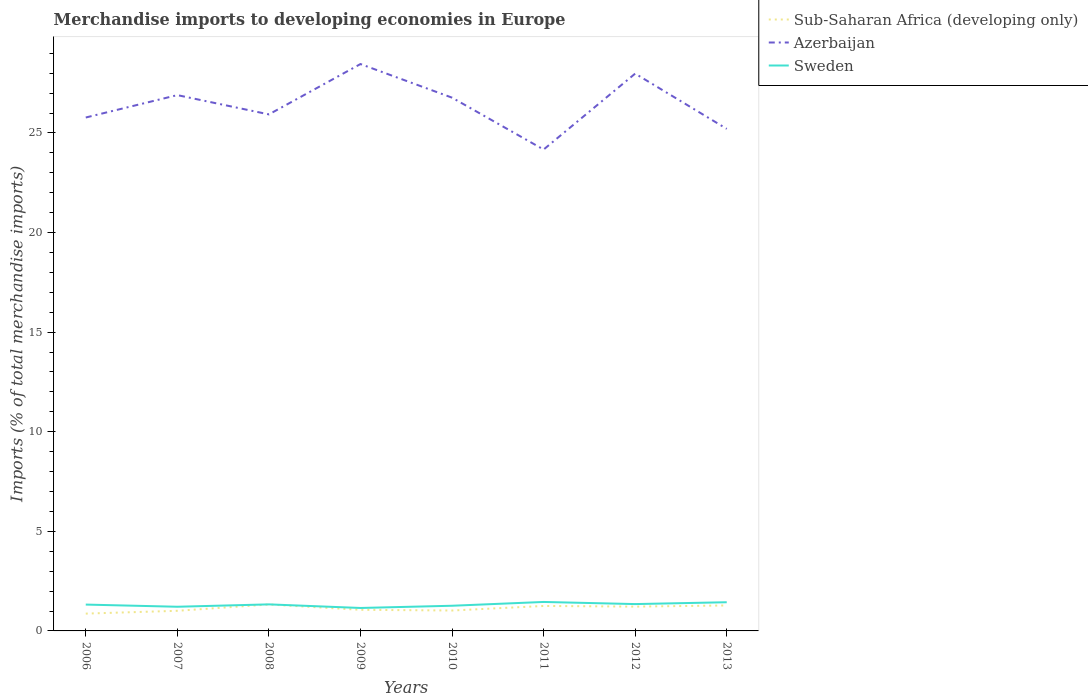How many different coloured lines are there?
Give a very brief answer. 3. Does the line corresponding to Azerbaijan intersect with the line corresponding to Sub-Saharan Africa (developing only)?
Provide a short and direct response. No. Is the number of lines equal to the number of legend labels?
Your answer should be compact. Yes. Across all years, what is the maximum percentage total merchandise imports in Azerbaijan?
Make the answer very short. 24.17. What is the total percentage total merchandise imports in Azerbaijan in the graph?
Give a very brief answer. -1.12. What is the difference between the highest and the second highest percentage total merchandise imports in Azerbaijan?
Offer a terse response. 4.29. What is the difference between the highest and the lowest percentage total merchandise imports in Sweden?
Provide a short and direct response. 5. How many lines are there?
Keep it short and to the point. 3. What is the difference between two consecutive major ticks on the Y-axis?
Make the answer very short. 5. Does the graph contain any zero values?
Make the answer very short. No. Where does the legend appear in the graph?
Provide a succinct answer. Top right. How many legend labels are there?
Provide a succinct answer. 3. How are the legend labels stacked?
Your answer should be compact. Vertical. What is the title of the graph?
Ensure brevity in your answer.  Merchandise imports to developing economies in Europe. What is the label or title of the X-axis?
Ensure brevity in your answer.  Years. What is the label or title of the Y-axis?
Offer a very short reply. Imports (% of total merchandise imports). What is the Imports (% of total merchandise imports) in Sub-Saharan Africa (developing only) in 2006?
Your answer should be compact. 0.87. What is the Imports (% of total merchandise imports) of Azerbaijan in 2006?
Your answer should be compact. 25.77. What is the Imports (% of total merchandise imports) of Sweden in 2006?
Provide a short and direct response. 1.32. What is the Imports (% of total merchandise imports) in Sub-Saharan Africa (developing only) in 2007?
Provide a succinct answer. 1.01. What is the Imports (% of total merchandise imports) in Azerbaijan in 2007?
Your response must be concise. 26.9. What is the Imports (% of total merchandise imports) in Sweden in 2007?
Your answer should be very brief. 1.21. What is the Imports (% of total merchandise imports) of Sub-Saharan Africa (developing only) in 2008?
Your answer should be very brief. 1.33. What is the Imports (% of total merchandise imports) of Azerbaijan in 2008?
Provide a short and direct response. 25.93. What is the Imports (% of total merchandise imports) in Sweden in 2008?
Give a very brief answer. 1.33. What is the Imports (% of total merchandise imports) of Sub-Saharan Africa (developing only) in 2009?
Ensure brevity in your answer.  1.06. What is the Imports (% of total merchandise imports) of Azerbaijan in 2009?
Make the answer very short. 28.46. What is the Imports (% of total merchandise imports) in Sweden in 2009?
Your answer should be compact. 1.15. What is the Imports (% of total merchandise imports) in Sub-Saharan Africa (developing only) in 2010?
Provide a succinct answer. 1.02. What is the Imports (% of total merchandise imports) of Azerbaijan in 2010?
Your answer should be very brief. 26.77. What is the Imports (% of total merchandise imports) of Sweden in 2010?
Provide a succinct answer. 1.26. What is the Imports (% of total merchandise imports) in Sub-Saharan Africa (developing only) in 2011?
Keep it short and to the point. 1.25. What is the Imports (% of total merchandise imports) in Azerbaijan in 2011?
Offer a very short reply. 24.17. What is the Imports (% of total merchandise imports) in Sweden in 2011?
Offer a terse response. 1.45. What is the Imports (% of total merchandise imports) of Sub-Saharan Africa (developing only) in 2012?
Offer a very short reply. 1.22. What is the Imports (% of total merchandise imports) in Azerbaijan in 2012?
Your response must be concise. 27.98. What is the Imports (% of total merchandise imports) of Sweden in 2012?
Offer a very short reply. 1.35. What is the Imports (% of total merchandise imports) of Sub-Saharan Africa (developing only) in 2013?
Ensure brevity in your answer.  1.28. What is the Imports (% of total merchandise imports) in Azerbaijan in 2013?
Give a very brief answer. 25.2. What is the Imports (% of total merchandise imports) of Sweden in 2013?
Give a very brief answer. 1.44. Across all years, what is the maximum Imports (% of total merchandise imports) in Sub-Saharan Africa (developing only)?
Offer a very short reply. 1.33. Across all years, what is the maximum Imports (% of total merchandise imports) in Azerbaijan?
Offer a terse response. 28.46. Across all years, what is the maximum Imports (% of total merchandise imports) of Sweden?
Make the answer very short. 1.45. Across all years, what is the minimum Imports (% of total merchandise imports) of Sub-Saharan Africa (developing only)?
Make the answer very short. 0.87. Across all years, what is the minimum Imports (% of total merchandise imports) of Azerbaijan?
Ensure brevity in your answer.  24.17. Across all years, what is the minimum Imports (% of total merchandise imports) in Sweden?
Your response must be concise. 1.15. What is the total Imports (% of total merchandise imports) in Sub-Saharan Africa (developing only) in the graph?
Offer a very short reply. 9.04. What is the total Imports (% of total merchandise imports) in Azerbaijan in the graph?
Keep it short and to the point. 211.18. What is the total Imports (% of total merchandise imports) of Sweden in the graph?
Provide a short and direct response. 10.53. What is the difference between the Imports (% of total merchandise imports) of Sub-Saharan Africa (developing only) in 2006 and that in 2007?
Offer a very short reply. -0.14. What is the difference between the Imports (% of total merchandise imports) of Azerbaijan in 2006 and that in 2007?
Your answer should be very brief. -1.12. What is the difference between the Imports (% of total merchandise imports) of Sweden in 2006 and that in 2007?
Offer a terse response. 0.11. What is the difference between the Imports (% of total merchandise imports) in Sub-Saharan Africa (developing only) in 2006 and that in 2008?
Keep it short and to the point. -0.46. What is the difference between the Imports (% of total merchandise imports) of Azerbaijan in 2006 and that in 2008?
Ensure brevity in your answer.  -0.16. What is the difference between the Imports (% of total merchandise imports) in Sweden in 2006 and that in 2008?
Give a very brief answer. -0.01. What is the difference between the Imports (% of total merchandise imports) of Sub-Saharan Africa (developing only) in 2006 and that in 2009?
Offer a very short reply. -0.19. What is the difference between the Imports (% of total merchandise imports) of Azerbaijan in 2006 and that in 2009?
Give a very brief answer. -2.68. What is the difference between the Imports (% of total merchandise imports) in Sweden in 2006 and that in 2009?
Keep it short and to the point. 0.17. What is the difference between the Imports (% of total merchandise imports) in Sub-Saharan Africa (developing only) in 2006 and that in 2010?
Make the answer very short. -0.16. What is the difference between the Imports (% of total merchandise imports) in Azerbaijan in 2006 and that in 2010?
Your answer should be very brief. -1. What is the difference between the Imports (% of total merchandise imports) of Sweden in 2006 and that in 2010?
Offer a very short reply. 0.06. What is the difference between the Imports (% of total merchandise imports) in Sub-Saharan Africa (developing only) in 2006 and that in 2011?
Your answer should be compact. -0.38. What is the difference between the Imports (% of total merchandise imports) in Azerbaijan in 2006 and that in 2011?
Ensure brevity in your answer.  1.61. What is the difference between the Imports (% of total merchandise imports) of Sweden in 2006 and that in 2011?
Your answer should be compact. -0.13. What is the difference between the Imports (% of total merchandise imports) in Sub-Saharan Africa (developing only) in 2006 and that in 2012?
Offer a terse response. -0.35. What is the difference between the Imports (% of total merchandise imports) in Azerbaijan in 2006 and that in 2012?
Make the answer very short. -2.2. What is the difference between the Imports (% of total merchandise imports) in Sweden in 2006 and that in 2012?
Make the answer very short. -0.03. What is the difference between the Imports (% of total merchandise imports) in Sub-Saharan Africa (developing only) in 2006 and that in 2013?
Give a very brief answer. -0.41. What is the difference between the Imports (% of total merchandise imports) of Azerbaijan in 2006 and that in 2013?
Keep it short and to the point. 0.57. What is the difference between the Imports (% of total merchandise imports) in Sweden in 2006 and that in 2013?
Ensure brevity in your answer.  -0.12. What is the difference between the Imports (% of total merchandise imports) of Sub-Saharan Africa (developing only) in 2007 and that in 2008?
Ensure brevity in your answer.  -0.32. What is the difference between the Imports (% of total merchandise imports) in Azerbaijan in 2007 and that in 2008?
Keep it short and to the point. 0.97. What is the difference between the Imports (% of total merchandise imports) of Sweden in 2007 and that in 2008?
Give a very brief answer. -0.12. What is the difference between the Imports (% of total merchandise imports) of Sub-Saharan Africa (developing only) in 2007 and that in 2009?
Offer a terse response. -0.05. What is the difference between the Imports (% of total merchandise imports) in Azerbaijan in 2007 and that in 2009?
Provide a short and direct response. -1.56. What is the difference between the Imports (% of total merchandise imports) of Sweden in 2007 and that in 2009?
Provide a short and direct response. 0.06. What is the difference between the Imports (% of total merchandise imports) of Sub-Saharan Africa (developing only) in 2007 and that in 2010?
Make the answer very short. -0.01. What is the difference between the Imports (% of total merchandise imports) of Azerbaijan in 2007 and that in 2010?
Your response must be concise. 0.13. What is the difference between the Imports (% of total merchandise imports) of Sweden in 2007 and that in 2010?
Keep it short and to the point. -0.05. What is the difference between the Imports (% of total merchandise imports) of Sub-Saharan Africa (developing only) in 2007 and that in 2011?
Offer a terse response. -0.24. What is the difference between the Imports (% of total merchandise imports) of Azerbaijan in 2007 and that in 2011?
Your answer should be very brief. 2.73. What is the difference between the Imports (% of total merchandise imports) in Sweden in 2007 and that in 2011?
Keep it short and to the point. -0.24. What is the difference between the Imports (% of total merchandise imports) in Sub-Saharan Africa (developing only) in 2007 and that in 2012?
Your response must be concise. -0.21. What is the difference between the Imports (% of total merchandise imports) in Azerbaijan in 2007 and that in 2012?
Give a very brief answer. -1.08. What is the difference between the Imports (% of total merchandise imports) in Sweden in 2007 and that in 2012?
Make the answer very short. -0.13. What is the difference between the Imports (% of total merchandise imports) in Sub-Saharan Africa (developing only) in 2007 and that in 2013?
Make the answer very short. -0.27. What is the difference between the Imports (% of total merchandise imports) of Azerbaijan in 2007 and that in 2013?
Ensure brevity in your answer.  1.69. What is the difference between the Imports (% of total merchandise imports) of Sweden in 2007 and that in 2013?
Provide a short and direct response. -0.23. What is the difference between the Imports (% of total merchandise imports) in Sub-Saharan Africa (developing only) in 2008 and that in 2009?
Keep it short and to the point. 0.27. What is the difference between the Imports (% of total merchandise imports) in Azerbaijan in 2008 and that in 2009?
Make the answer very short. -2.53. What is the difference between the Imports (% of total merchandise imports) of Sweden in 2008 and that in 2009?
Make the answer very short. 0.18. What is the difference between the Imports (% of total merchandise imports) of Sub-Saharan Africa (developing only) in 2008 and that in 2010?
Offer a very short reply. 0.3. What is the difference between the Imports (% of total merchandise imports) of Azerbaijan in 2008 and that in 2010?
Your response must be concise. -0.84. What is the difference between the Imports (% of total merchandise imports) of Sweden in 2008 and that in 2010?
Provide a short and direct response. 0.07. What is the difference between the Imports (% of total merchandise imports) of Sub-Saharan Africa (developing only) in 2008 and that in 2011?
Keep it short and to the point. 0.07. What is the difference between the Imports (% of total merchandise imports) in Azerbaijan in 2008 and that in 2011?
Give a very brief answer. 1.76. What is the difference between the Imports (% of total merchandise imports) of Sweden in 2008 and that in 2011?
Ensure brevity in your answer.  -0.12. What is the difference between the Imports (% of total merchandise imports) in Sub-Saharan Africa (developing only) in 2008 and that in 2012?
Make the answer very short. 0.11. What is the difference between the Imports (% of total merchandise imports) in Azerbaijan in 2008 and that in 2012?
Make the answer very short. -2.05. What is the difference between the Imports (% of total merchandise imports) in Sweden in 2008 and that in 2012?
Your answer should be compact. -0.01. What is the difference between the Imports (% of total merchandise imports) in Sub-Saharan Africa (developing only) in 2008 and that in 2013?
Offer a terse response. 0.05. What is the difference between the Imports (% of total merchandise imports) in Azerbaijan in 2008 and that in 2013?
Provide a succinct answer. 0.73. What is the difference between the Imports (% of total merchandise imports) of Sweden in 2008 and that in 2013?
Offer a terse response. -0.11. What is the difference between the Imports (% of total merchandise imports) in Sub-Saharan Africa (developing only) in 2009 and that in 2010?
Keep it short and to the point. 0.04. What is the difference between the Imports (% of total merchandise imports) in Azerbaijan in 2009 and that in 2010?
Provide a short and direct response. 1.69. What is the difference between the Imports (% of total merchandise imports) in Sweden in 2009 and that in 2010?
Offer a very short reply. -0.11. What is the difference between the Imports (% of total merchandise imports) in Sub-Saharan Africa (developing only) in 2009 and that in 2011?
Offer a very short reply. -0.19. What is the difference between the Imports (% of total merchandise imports) of Azerbaijan in 2009 and that in 2011?
Provide a short and direct response. 4.29. What is the difference between the Imports (% of total merchandise imports) in Sweden in 2009 and that in 2011?
Offer a terse response. -0.3. What is the difference between the Imports (% of total merchandise imports) of Sub-Saharan Africa (developing only) in 2009 and that in 2012?
Your answer should be compact. -0.16. What is the difference between the Imports (% of total merchandise imports) in Azerbaijan in 2009 and that in 2012?
Your response must be concise. 0.48. What is the difference between the Imports (% of total merchandise imports) of Sweden in 2009 and that in 2012?
Offer a very short reply. -0.19. What is the difference between the Imports (% of total merchandise imports) in Sub-Saharan Africa (developing only) in 2009 and that in 2013?
Make the answer very short. -0.22. What is the difference between the Imports (% of total merchandise imports) in Azerbaijan in 2009 and that in 2013?
Your answer should be compact. 3.25. What is the difference between the Imports (% of total merchandise imports) in Sweden in 2009 and that in 2013?
Make the answer very short. -0.29. What is the difference between the Imports (% of total merchandise imports) in Sub-Saharan Africa (developing only) in 2010 and that in 2011?
Offer a very short reply. -0.23. What is the difference between the Imports (% of total merchandise imports) in Azerbaijan in 2010 and that in 2011?
Keep it short and to the point. 2.6. What is the difference between the Imports (% of total merchandise imports) in Sweden in 2010 and that in 2011?
Your answer should be compact. -0.19. What is the difference between the Imports (% of total merchandise imports) in Sub-Saharan Africa (developing only) in 2010 and that in 2012?
Make the answer very short. -0.2. What is the difference between the Imports (% of total merchandise imports) in Azerbaijan in 2010 and that in 2012?
Your answer should be very brief. -1.21. What is the difference between the Imports (% of total merchandise imports) of Sweden in 2010 and that in 2012?
Provide a short and direct response. -0.08. What is the difference between the Imports (% of total merchandise imports) in Sub-Saharan Africa (developing only) in 2010 and that in 2013?
Your answer should be compact. -0.25. What is the difference between the Imports (% of total merchandise imports) of Azerbaijan in 2010 and that in 2013?
Your answer should be compact. 1.57. What is the difference between the Imports (% of total merchandise imports) in Sweden in 2010 and that in 2013?
Your response must be concise. -0.18. What is the difference between the Imports (% of total merchandise imports) in Sub-Saharan Africa (developing only) in 2011 and that in 2012?
Ensure brevity in your answer.  0.03. What is the difference between the Imports (% of total merchandise imports) in Azerbaijan in 2011 and that in 2012?
Offer a very short reply. -3.81. What is the difference between the Imports (% of total merchandise imports) of Sweden in 2011 and that in 2012?
Make the answer very short. 0.11. What is the difference between the Imports (% of total merchandise imports) in Sub-Saharan Africa (developing only) in 2011 and that in 2013?
Your answer should be very brief. -0.03. What is the difference between the Imports (% of total merchandise imports) in Azerbaijan in 2011 and that in 2013?
Keep it short and to the point. -1.04. What is the difference between the Imports (% of total merchandise imports) of Sweden in 2011 and that in 2013?
Ensure brevity in your answer.  0.01. What is the difference between the Imports (% of total merchandise imports) of Sub-Saharan Africa (developing only) in 2012 and that in 2013?
Keep it short and to the point. -0.06. What is the difference between the Imports (% of total merchandise imports) of Azerbaijan in 2012 and that in 2013?
Make the answer very short. 2.77. What is the difference between the Imports (% of total merchandise imports) of Sweden in 2012 and that in 2013?
Your answer should be very brief. -0.09. What is the difference between the Imports (% of total merchandise imports) of Sub-Saharan Africa (developing only) in 2006 and the Imports (% of total merchandise imports) of Azerbaijan in 2007?
Your response must be concise. -26.03. What is the difference between the Imports (% of total merchandise imports) of Sub-Saharan Africa (developing only) in 2006 and the Imports (% of total merchandise imports) of Sweden in 2007?
Keep it short and to the point. -0.34. What is the difference between the Imports (% of total merchandise imports) in Azerbaijan in 2006 and the Imports (% of total merchandise imports) in Sweden in 2007?
Keep it short and to the point. 24.56. What is the difference between the Imports (% of total merchandise imports) of Sub-Saharan Africa (developing only) in 2006 and the Imports (% of total merchandise imports) of Azerbaijan in 2008?
Give a very brief answer. -25.06. What is the difference between the Imports (% of total merchandise imports) in Sub-Saharan Africa (developing only) in 2006 and the Imports (% of total merchandise imports) in Sweden in 2008?
Keep it short and to the point. -0.46. What is the difference between the Imports (% of total merchandise imports) of Azerbaijan in 2006 and the Imports (% of total merchandise imports) of Sweden in 2008?
Your answer should be very brief. 24.44. What is the difference between the Imports (% of total merchandise imports) of Sub-Saharan Africa (developing only) in 2006 and the Imports (% of total merchandise imports) of Azerbaijan in 2009?
Your answer should be very brief. -27.59. What is the difference between the Imports (% of total merchandise imports) in Sub-Saharan Africa (developing only) in 2006 and the Imports (% of total merchandise imports) in Sweden in 2009?
Offer a terse response. -0.28. What is the difference between the Imports (% of total merchandise imports) in Azerbaijan in 2006 and the Imports (% of total merchandise imports) in Sweden in 2009?
Provide a succinct answer. 24.62. What is the difference between the Imports (% of total merchandise imports) of Sub-Saharan Africa (developing only) in 2006 and the Imports (% of total merchandise imports) of Azerbaijan in 2010?
Provide a succinct answer. -25.9. What is the difference between the Imports (% of total merchandise imports) of Sub-Saharan Africa (developing only) in 2006 and the Imports (% of total merchandise imports) of Sweden in 2010?
Provide a short and direct response. -0.39. What is the difference between the Imports (% of total merchandise imports) in Azerbaijan in 2006 and the Imports (% of total merchandise imports) in Sweden in 2010?
Provide a short and direct response. 24.51. What is the difference between the Imports (% of total merchandise imports) of Sub-Saharan Africa (developing only) in 2006 and the Imports (% of total merchandise imports) of Azerbaijan in 2011?
Provide a short and direct response. -23.3. What is the difference between the Imports (% of total merchandise imports) of Sub-Saharan Africa (developing only) in 2006 and the Imports (% of total merchandise imports) of Sweden in 2011?
Make the answer very short. -0.58. What is the difference between the Imports (% of total merchandise imports) of Azerbaijan in 2006 and the Imports (% of total merchandise imports) of Sweden in 2011?
Provide a short and direct response. 24.32. What is the difference between the Imports (% of total merchandise imports) in Sub-Saharan Africa (developing only) in 2006 and the Imports (% of total merchandise imports) in Azerbaijan in 2012?
Provide a short and direct response. -27.11. What is the difference between the Imports (% of total merchandise imports) of Sub-Saharan Africa (developing only) in 2006 and the Imports (% of total merchandise imports) of Sweden in 2012?
Provide a succinct answer. -0.48. What is the difference between the Imports (% of total merchandise imports) of Azerbaijan in 2006 and the Imports (% of total merchandise imports) of Sweden in 2012?
Provide a succinct answer. 24.43. What is the difference between the Imports (% of total merchandise imports) of Sub-Saharan Africa (developing only) in 2006 and the Imports (% of total merchandise imports) of Azerbaijan in 2013?
Your answer should be very brief. -24.34. What is the difference between the Imports (% of total merchandise imports) in Sub-Saharan Africa (developing only) in 2006 and the Imports (% of total merchandise imports) in Sweden in 2013?
Provide a succinct answer. -0.57. What is the difference between the Imports (% of total merchandise imports) in Azerbaijan in 2006 and the Imports (% of total merchandise imports) in Sweden in 2013?
Your answer should be compact. 24.33. What is the difference between the Imports (% of total merchandise imports) of Sub-Saharan Africa (developing only) in 2007 and the Imports (% of total merchandise imports) of Azerbaijan in 2008?
Provide a succinct answer. -24.92. What is the difference between the Imports (% of total merchandise imports) of Sub-Saharan Africa (developing only) in 2007 and the Imports (% of total merchandise imports) of Sweden in 2008?
Give a very brief answer. -0.32. What is the difference between the Imports (% of total merchandise imports) of Azerbaijan in 2007 and the Imports (% of total merchandise imports) of Sweden in 2008?
Provide a succinct answer. 25.57. What is the difference between the Imports (% of total merchandise imports) of Sub-Saharan Africa (developing only) in 2007 and the Imports (% of total merchandise imports) of Azerbaijan in 2009?
Give a very brief answer. -27.45. What is the difference between the Imports (% of total merchandise imports) in Sub-Saharan Africa (developing only) in 2007 and the Imports (% of total merchandise imports) in Sweden in 2009?
Offer a terse response. -0.14. What is the difference between the Imports (% of total merchandise imports) of Azerbaijan in 2007 and the Imports (% of total merchandise imports) of Sweden in 2009?
Offer a terse response. 25.75. What is the difference between the Imports (% of total merchandise imports) in Sub-Saharan Africa (developing only) in 2007 and the Imports (% of total merchandise imports) in Azerbaijan in 2010?
Keep it short and to the point. -25.76. What is the difference between the Imports (% of total merchandise imports) in Sub-Saharan Africa (developing only) in 2007 and the Imports (% of total merchandise imports) in Sweden in 2010?
Your answer should be very brief. -0.25. What is the difference between the Imports (% of total merchandise imports) of Azerbaijan in 2007 and the Imports (% of total merchandise imports) of Sweden in 2010?
Provide a short and direct response. 25.63. What is the difference between the Imports (% of total merchandise imports) in Sub-Saharan Africa (developing only) in 2007 and the Imports (% of total merchandise imports) in Azerbaijan in 2011?
Ensure brevity in your answer.  -23.16. What is the difference between the Imports (% of total merchandise imports) in Sub-Saharan Africa (developing only) in 2007 and the Imports (% of total merchandise imports) in Sweden in 2011?
Provide a short and direct response. -0.44. What is the difference between the Imports (% of total merchandise imports) of Azerbaijan in 2007 and the Imports (% of total merchandise imports) of Sweden in 2011?
Offer a terse response. 25.44. What is the difference between the Imports (% of total merchandise imports) of Sub-Saharan Africa (developing only) in 2007 and the Imports (% of total merchandise imports) of Azerbaijan in 2012?
Give a very brief answer. -26.97. What is the difference between the Imports (% of total merchandise imports) of Sub-Saharan Africa (developing only) in 2007 and the Imports (% of total merchandise imports) of Sweden in 2012?
Offer a very short reply. -0.34. What is the difference between the Imports (% of total merchandise imports) in Azerbaijan in 2007 and the Imports (% of total merchandise imports) in Sweden in 2012?
Give a very brief answer. 25.55. What is the difference between the Imports (% of total merchandise imports) of Sub-Saharan Africa (developing only) in 2007 and the Imports (% of total merchandise imports) of Azerbaijan in 2013?
Provide a short and direct response. -24.19. What is the difference between the Imports (% of total merchandise imports) of Sub-Saharan Africa (developing only) in 2007 and the Imports (% of total merchandise imports) of Sweden in 2013?
Provide a short and direct response. -0.43. What is the difference between the Imports (% of total merchandise imports) of Azerbaijan in 2007 and the Imports (% of total merchandise imports) of Sweden in 2013?
Provide a short and direct response. 25.46. What is the difference between the Imports (% of total merchandise imports) of Sub-Saharan Africa (developing only) in 2008 and the Imports (% of total merchandise imports) of Azerbaijan in 2009?
Your response must be concise. -27.13. What is the difference between the Imports (% of total merchandise imports) in Sub-Saharan Africa (developing only) in 2008 and the Imports (% of total merchandise imports) in Sweden in 2009?
Offer a terse response. 0.17. What is the difference between the Imports (% of total merchandise imports) in Azerbaijan in 2008 and the Imports (% of total merchandise imports) in Sweden in 2009?
Provide a succinct answer. 24.78. What is the difference between the Imports (% of total merchandise imports) in Sub-Saharan Africa (developing only) in 2008 and the Imports (% of total merchandise imports) in Azerbaijan in 2010?
Offer a terse response. -25.44. What is the difference between the Imports (% of total merchandise imports) of Sub-Saharan Africa (developing only) in 2008 and the Imports (% of total merchandise imports) of Sweden in 2010?
Offer a very short reply. 0.06. What is the difference between the Imports (% of total merchandise imports) in Azerbaijan in 2008 and the Imports (% of total merchandise imports) in Sweden in 2010?
Give a very brief answer. 24.67. What is the difference between the Imports (% of total merchandise imports) in Sub-Saharan Africa (developing only) in 2008 and the Imports (% of total merchandise imports) in Azerbaijan in 2011?
Your answer should be compact. -22.84. What is the difference between the Imports (% of total merchandise imports) in Sub-Saharan Africa (developing only) in 2008 and the Imports (% of total merchandise imports) in Sweden in 2011?
Make the answer very short. -0.13. What is the difference between the Imports (% of total merchandise imports) in Azerbaijan in 2008 and the Imports (% of total merchandise imports) in Sweden in 2011?
Provide a short and direct response. 24.48. What is the difference between the Imports (% of total merchandise imports) in Sub-Saharan Africa (developing only) in 2008 and the Imports (% of total merchandise imports) in Azerbaijan in 2012?
Your response must be concise. -26.65. What is the difference between the Imports (% of total merchandise imports) in Sub-Saharan Africa (developing only) in 2008 and the Imports (% of total merchandise imports) in Sweden in 2012?
Provide a short and direct response. -0.02. What is the difference between the Imports (% of total merchandise imports) in Azerbaijan in 2008 and the Imports (% of total merchandise imports) in Sweden in 2012?
Give a very brief answer. 24.58. What is the difference between the Imports (% of total merchandise imports) in Sub-Saharan Africa (developing only) in 2008 and the Imports (% of total merchandise imports) in Azerbaijan in 2013?
Your response must be concise. -23.88. What is the difference between the Imports (% of total merchandise imports) of Sub-Saharan Africa (developing only) in 2008 and the Imports (% of total merchandise imports) of Sweden in 2013?
Provide a succinct answer. -0.11. What is the difference between the Imports (% of total merchandise imports) of Azerbaijan in 2008 and the Imports (% of total merchandise imports) of Sweden in 2013?
Offer a terse response. 24.49. What is the difference between the Imports (% of total merchandise imports) of Sub-Saharan Africa (developing only) in 2009 and the Imports (% of total merchandise imports) of Azerbaijan in 2010?
Offer a very short reply. -25.71. What is the difference between the Imports (% of total merchandise imports) of Sub-Saharan Africa (developing only) in 2009 and the Imports (% of total merchandise imports) of Sweden in 2010?
Provide a short and direct response. -0.2. What is the difference between the Imports (% of total merchandise imports) of Azerbaijan in 2009 and the Imports (% of total merchandise imports) of Sweden in 2010?
Provide a short and direct response. 27.19. What is the difference between the Imports (% of total merchandise imports) in Sub-Saharan Africa (developing only) in 2009 and the Imports (% of total merchandise imports) in Azerbaijan in 2011?
Your answer should be compact. -23.11. What is the difference between the Imports (% of total merchandise imports) in Sub-Saharan Africa (developing only) in 2009 and the Imports (% of total merchandise imports) in Sweden in 2011?
Offer a very short reply. -0.39. What is the difference between the Imports (% of total merchandise imports) of Azerbaijan in 2009 and the Imports (% of total merchandise imports) of Sweden in 2011?
Provide a succinct answer. 27. What is the difference between the Imports (% of total merchandise imports) of Sub-Saharan Africa (developing only) in 2009 and the Imports (% of total merchandise imports) of Azerbaijan in 2012?
Make the answer very short. -26.92. What is the difference between the Imports (% of total merchandise imports) of Sub-Saharan Africa (developing only) in 2009 and the Imports (% of total merchandise imports) of Sweden in 2012?
Your answer should be very brief. -0.29. What is the difference between the Imports (% of total merchandise imports) of Azerbaijan in 2009 and the Imports (% of total merchandise imports) of Sweden in 2012?
Make the answer very short. 27.11. What is the difference between the Imports (% of total merchandise imports) in Sub-Saharan Africa (developing only) in 2009 and the Imports (% of total merchandise imports) in Azerbaijan in 2013?
Give a very brief answer. -24.14. What is the difference between the Imports (% of total merchandise imports) in Sub-Saharan Africa (developing only) in 2009 and the Imports (% of total merchandise imports) in Sweden in 2013?
Offer a very short reply. -0.38. What is the difference between the Imports (% of total merchandise imports) in Azerbaijan in 2009 and the Imports (% of total merchandise imports) in Sweden in 2013?
Your answer should be very brief. 27.02. What is the difference between the Imports (% of total merchandise imports) of Sub-Saharan Africa (developing only) in 2010 and the Imports (% of total merchandise imports) of Azerbaijan in 2011?
Your answer should be very brief. -23.14. What is the difference between the Imports (% of total merchandise imports) in Sub-Saharan Africa (developing only) in 2010 and the Imports (% of total merchandise imports) in Sweden in 2011?
Ensure brevity in your answer.  -0.43. What is the difference between the Imports (% of total merchandise imports) in Azerbaijan in 2010 and the Imports (% of total merchandise imports) in Sweden in 2011?
Your answer should be very brief. 25.32. What is the difference between the Imports (% of total merchandise imports) of Sub-Saharan Africa (developing only) in 2010 and the Imports (% of total merchandise imports) of Azerbaijan in 2012?
Give a very brief answer. -26.95. What is the difference between the Imports (% of total merchandise imports) of Sub-Saharan Africa (developing only) in 2010 and the Imports (% of total merchandise imports) of Sweden in 2012?
Provide a succinct answer. -0.32. What is the difference between the Imports (% of total merchandise imports) of Azerbaijan in 2010 and the Imports (% of total merchandise imports) of Sweden in 2012?
Your response must be concise. 25.42. What is the difference between the Imports (% of total merchandise imports) in Sub-Saharan Africa (developing only) in 2010 and the Imports (% of total merchandise imports) in Azerbaijan in 2013?
Give a very brief answer. -24.18. What is the difference between the Imports (% of total merchandise imports) in Sub-Saharan Africa (developing only) in 2010 and the Imports (% of total merchandise imports) in Sweden in 2013?
Your answer should be compact. -0.42. What is the difference between the Imports (% of total merchandise imports) in Azerbaijan in 2010 and the Imports (% of total merchandise imports) in Sweden in 2013?
Keep it short and to the point. 25.33. What is the difference between the Imports (% of total merchandise imports) in Sub-Saharan Africa (developing only) in 2011 and the Imports (% of total merchandise imports) in Azerbaijan in 2012?
Give a very brief answer. -26.72. What is the difference between the Imports (% of total merchandise imports) in Sub-Saharan Africa (developing only) in 2011 and the Imports (% of total merchandise imports) in Sweden in 2012?
Offer a very short reply. -0.09. What is the difference between the Imports (% of total merchandise imports) of Azerbaijan in 2011 and the Imports (% of total merchandise imports) of Sweden in 2012?
Keep it short and to the point. 22.82. What is the difference between the Imports (% of total merchandise imports) of Sub-Saharan Africa (developing only) in 2011 and the Imports (% of total merchandise imports) of Azerbaijan in 2013?
Provide a short and direct response. -23.95. What is the difference between the Imports (% of total merchandise imports) of Sub-Saharan Africa (developing only) in 2011 and the Imports (% of total merchandise imports) of Sweden in 2013?
Your answer should be compact. -0.19. What is the difference between the Imports (% of total merchandise imports) in Azerbaijan in 2011 and the Imports (% of total merchandise imports) in Sweden in 2013?
Provide a short and direct response. 22.73. What is the difference between the Imports (% of total merchandise imports) of Sub-Saharan Africa (developing only) in 2012 and the Imports (% of total merchandise imports) of Azerbaijan in 2013?
Make the answer very short. -23.98. What is the difference between the Imports (% of total merchandise imports) of Sub-Saharan Africa (developing only) in 2012 and the Imports (% of total merchandise imports) of Sweden in 2013?
Give a very brief answer. -0.22. What is the difference between the Imports (% of total merchandise imports) of Azerbaijan in 2012 and the Imports (% of total merchandise imports) of Sweden in 2013?
Offer a terse response. 26.54. What is the average Imports (% of total merchandise imports) in Sub-Saharan Africa (developing only) per year?
Provide a short and direct response. 1.13. What is the average Imports (% of total merchandise imports) in Azerbaijan per year?
Provide a succinct answer. 26.4. What is the average Imports (% of total merchandise imports) of Sweden per year?
Offer a terse response. 1.32. In the year 2006, what is the difference between the Imports (% of total merchandise imports) in Sub-Saharan Africa (developing only) and Imports (% of total merchandise imports) in Azerbaijan?
Offer a very short reply. -24.9. In the year 2006, what is the difference between the Imports (% of total merchandise imports) of Sub-Saharan Africa (developing only) and Imports (% of total merchandise imports) of Sweden?
Your response must be concise. -0.45. In the year 2006, what is the difference between the Imports (% of total merchandise imports) of Azerbaijan and Imports (% of total merchandise imports) of Sweden?
Provide a short and direct response. 24.45. In the year 2007, what is the difference between the Imports (% of total merchandise imports) in Sub-Saharan Africa (developing only) and Imports (% of total merchandise imports) in Azerbaijan?
Ensure brevity in your answer.  -25.89. In the year 2007, what is the difference between the Imports (% of total merchandise imports) in Sub-Saharan Africa (developing only) and Imports (% of total merchandise imports) in Sweden?
Keep it short and to the point. -0.2. In the year 2007, what is the difference between the Imports (% of total merchandise imports) of Azerbaijan and Imports (% of total merchandise imports) of Sweden?
Your answer should be very brief. 25.69. In the year 2008, what is the difference between the Imports (% of total merchandise imports) in Sub-Saharan Africa (developing only) and Imports (% of total merchandise imports) in Azerbaijan?
Your answer should be very brief. -24.6. In the year 2008, what is the difference between the Imports (% of total merchandise imports) in Sub-Saharan Africa (developing only) and Imports (% of total merchandise imports) in Sweden?
Provide a short and direct response. -0.01. In the year 2008, what is the difference between the Imports (% of total merchandise imports) of Azerbaijan and Imports (% of total merchandise imports) of Sweden?
Make the answer very short. 24.6. In the year 2009, what is the difference between the Imports (% of total merchandise imports) of Sub-Saharan Africa (developing only) and Imports (% of total merchandise imports) of Azerbaijan?
Provide a short and direct response. -27.4. In the year 2009, what is the difference between the Imports (% of total merchandise imports) in Sub-Saharan Africa (developing only) and Imports (% of total merchandise imports) in Sweden?
Keep it short and to the point. -0.09. In the year 2009, what is the difference between the Imports (% of total merchandise imports) in Azerbaijan and Imports (% of total merchandise imports) in Sweden?
Your response must be concise. 27.31. In the year 2010, what is the difference between the Imports (% of total merchandise imports) of Sub-Saharan Africa (developing only) and Imports (% of total merchandise imports) of Azerbaijan?
Your response must be concise. -25.75. In the year 2010, what is the difference between the Imports (% of total merchandise imports) in Sub-Saharan Africa (developing only) and Imports (% of total merchandise imports) in Sweden?
Your answer should be compact. -0.24. In the year 2010, what is the difference between the Imports (% of total merchandise imports) of Azerbaijan and Imports (% of total merchandise imports) of Sweden?
Your answer should be very brief. 25.51. In the year 2011, what is the difference between the Imports (% of total merchandise imports) of Sub-Saharan Africa (developing only) and Imports (% of total merchandise imports) of Azerbaijan?
Your answer should be compact. -22.91. In the year 2011, what is the difference between the Imports (% of total merchandise imports) in Sub-Saharan Africa (developing only) and Imports (% of total merchandise imports) in Sweden?
Provide a short and direct response. -0.2. In the year 2011, what is the difference between the Imports (% of total merchandise imports) of Azerbaijan and Imports (% of total merchandise imports) of Sweden?
Your answer should be very brief. 22.71. In the year 2012, what is the difference between the Imports (% of total merchandise imports) of Sub-Saharan Africa (developing only) and Imports (% of total merchandise imports) of Azerbaijan?
Provide a short and direct response. -26.76. In the year 2012, what is the difference between the Imports (% of total merchandise imports) of Sub-Saharan Africa (developing only) and Imports (% of total merchandise imports) of Sweden?
Provide a short and direct response. -0.13. In the year 2012, what is the difference between the Imports (% of total merchandise imports) in Azerbaijan and Imports (% of total merchandise imports) in Sweden?
Your answer should be very brief. 26.63. In the year 2013, what is the difference between the Imports (% of total merchandise imports) in Sub-Saharan Africa (developing only) and Imports (% of total merchandise imports) in Azerbaijan?
Give a very brief answer. -23.93. In the year 2013, what is the difference between the Imports (% of total merchandise imports) in Sub-Saharan Africa (developing only) and Imports (% of total merchandise imports) in Sweden?
Provide a short and direct response. -0.16. In the year 2013, what is the difference between the Imports (% of total merchandise imports) in Azerbaijan and Imports (% of total merchandise imports) in Sweden?
Offer a terse response. 23.76. What is the ratio of the Imports (% of total merchandise imports) in Sub-Saharan Africa (developing only) in 2006 to that in 2007?
Ensure brevity in your answer.  0.86. What is the ratio of the Imports (% of total merchandise imports) in Azerbaijan in 2006 to that in 2007?
Offer a terse response. 0.96. What is the ratio of the Imports (% of total merchandise imports) in Sweden in 2006 to that in 2007?
Offer a very short reply. 1.09. What is the ratio of the Imports (% of total merchandise imports) of Sub-Saharan Africa (developing only) in 2006 to that in 2008?
Make the answer very short. 0.65. What is the ratio of the Imports (% of total merchandise imports) in Azerbaijan in 2006 to that in 2008?
Your answer should be very brief. 0.99. What is the ratio of the Imports (% of total merchandise imports) of Sweden in 2006 to that in 2008?
Your response must be concise. 0.99. What is the ratio of the Imports (% of total merchandise imports) in Sub-Saharan Africa (developing only) in 2006 to that in 2009?
Give a very brief answer. 0.82. What is the ratio of the Imports (% of total merchandise imports) of Azerbaijan in 2006 to that in 2009?
Provide a short and direct response. 0.91. What is the ratio of the Imports (% of total merchandise imports) in Sweden in 2006 to that in 2009?
Provide a short and direct response. 1.15. What is the ratio of the Imports (% of total merchandise imports) in Sub-Saharan Africa (developing only) in 2006 to that in 2010?
Your answer should be compact. 0.85. What is the ratio of the Imports (% of total merchandise imports) in Azerbaijan in 2006 to that in 2010?
Offer a very short reply. 0.96. What is the ratio of the Imports (% of total merchandise imports) of Sweden in 2006 to that in 2010?
Your answer should be compact. 1.05. What is the ratio of the Imports (% of total merchandise imports) in Sub-Saharan Africa (developing only) in 2006 to that in 2011?
Make the answer very short. 0.69. What is the ratio of the Imports (% of total merchandise imports) of Azerbaijan in 2006 to that in 2011?
Make the answer very short. 1.07. What is the ratio of the Imports (% of total merchandise imports) of Sweden in 2006 to that in 2011?
Give a very brief answer. 0.91. What is the ratio of the Imports (% of total merchandise imports) in Sub-Saharan Africa (developing only) in 2006 to that in 2012?
Your answer should be compact. 0.71. What is the ratio of the Imports (% of total merchandise imports) of Azerbaijan in 2006 to that in 2012?
Offer a terse response. 0.92. What is the ratio of the Imports (% of total merchandise imports) in Sweden in 2006 to that in 2012?
Offer a terse response. 0.98. What is the ratio of the Imports (% of total merchandise imports) of Sub-Saharan Africa (developing only) in 2006 to that in 2013?
Make the answer very short. 0.68. What is the ratio of the Imports (% of total merchandise imports) of Azerbaijan in 2006 to that in 2013?
Provide a succinct answer. 1.02. What is the ratio of the Imports (% of total merchandise imports) in Sweden in 2006 to that in 2013?
Your answer should be compact. 0.92. What is the ratio of the Imports (% of total merchandise imports) in Sub-Saharan Africa (developing only) in 2007 to that in 2008?
Give a very brief answer. 0.76. What is the ratio of the Imports (% of total merchandise imports) of Azerbaijan in 2007 to that in 2008?
Keep it short and to the point. 1.04. What is the ratio of the Imports (% of total merchandise imports) of Sweden in 2007 to that in 2008?
Provide a succinct answer. 0.91. What is the ratio of the Imports (% of total merchandise imports) of Sub-Saharan Africa (developing only) in 2007 to that in 2009?
Ensure brevity in your answer.  0.95. What is the ratio of the Imports (% of total merchandise imports) of Azerbaijan in 2007 to that in 2009?
Provide a short and direct response. 0.95. What is the ratio of the Imports (% of total merchandise imports) in Sweden in 2007 to that in 2009?
Keep it short and to the point. 1.05. What is the ratio of the Imports (% of total merchandise imports) of Sub-Saharan Africa (developing only) in 2007 to that in 2010?
Provide a short and direct response. 0.99. What is the ratio of the Imports (% of total merchandise imports) of Azerbaijan in 2007 to that in 2010?
Offer a very short reply. 1. What is the ratio of the Imports (% of total merchandise imports) in Sub-Saharan Africa (developing only) in 2007 to that in 2011?
Your answer should be very brief. 0.81. What is the ratio of the Imports (% of total merchandise imports) of Azerbaijan in 2007 to that in 2011?
Provide a short and direct response. 1.11. What is the ratio of the Imports (% of total merchandise imports) of Sweden in 2007 to that in 2011?
Ensure brevity in your answer.  0.83. What is the ratio of the Imports (% of total merchandise imports) in Sub-Saharan Africa (developing only) in 2007 to that in 2012?
Make the answer very short. 0.83. What is the ratio of the Imports (% of total merchandise imports) of Azerbaijan in 2007 to that in 2012?
Make the answer very short. 0.96. What is the ratio of the Imports (% of total merchandise imports) in Sweden in 2007 to that in 2012?
Your response must be concise. 0.9. What is the ratio of the Imports (% of total merchandise imports) in Sub-Saharan Africa (developing only) in 2007 to that in 2013?
Make the answer very short. 0.79. What is the ratio of the Imports (% of total merchandise imports) of Azerbaijan in 2007 to that in 2013?
Your answer should be compact. 1.07. What is the ratio of the Imports (% of total merchandise imports) of Sweden in 2007 to that in 2013?
Provide a short and direct response. 0.84. What is the ratio of the Imports (% of total merchandise imports) in Sub-Saharan Africa (developing only) in 2008 to that in 2009?
Provide a short and direct response. 1.25. What is the ratio of the Imports (% of total merchandise imports) in Azerbaijan in 2008 to that in 2009?
Give a very brief answer. 0.91. What is the ratio of the Imports (% of total merchandise imports) of Sweden in 2008 to that in 2009?
Give a very brief answer. 1.16. What is the ratio of the Imports (% of total merchandise imports) of Sub-Saharan Africa (developing only) in 2008 to that in 2010?
Provide a succinct answer. 1.3. What is the ratio of the Imports (% of total merchandise imports) of Azerbaijan in 2008 to that in 2010?
Your response must be concise. 0.97. What is the ratio of the Imports (% of total merchandise imports) in Sweden in 2008 to that in 2010?
Provide a succinct answer. 1.05. What is the ratio of the Imports (% of total merchandise imports) in Sub-Saharan Africa (developing only) in 2008 to that in 2011?
Provide a short and direct response. 1.06. What is the ratio of the Imports (% of total merchandise imports) of Azerbaijan in 2008 to that in 2011?
Provide a succinct answer. 1.07. What is the ratio of the Imports (% of total merchandise imports) in Sweden in 2008 to that in 2011?
Offer a very short reply. 0.92. What is the ratio of the Imports (% of total merchandise imports) of Sub-Saharan Africa (developing only) in 2008 to that in 2012?
Offer a terse response. 1.09. What is the ratio of the Imports (% of total merchandise imports) of Azerbaijan in 2008 to that in 2012?
Keep it short and to the point. 0.93. What is the ratio of the Imports (% of total merchandise imports) in Sweden in 2008 to that in 2012?
Ensure brevity in your answer.  0.99. What is the ratio of the Imports (% of total merchandise imports) in Sub-Saharan Africa (developing only) in 2008 to that in 2013?
Offer a terse response. 1.04. What is the ratio of the Imports (% of total merchandise imports) of Azerbaijan in 2008 to that in 2013?
Provide a succinct answer. 1.03. What is the ratio of the Imports (% of total merchandise imports) of Sweden in 2008 to that in 2013?
Make the answer very short. 0.93. What is the ratio of the Imports (% of total merchandise imports) in Sub-Saharan Africa (developing only) in 2009 to that in 2010?
Offer a very short reply. 1.03. What is the ratio of the Imports (% of total merchandise imports) of Azerbaijan in 2009 to that in 2010?
Your response must be concise. 1.06. What is the ratio of the Imports (% of total merchandise imports) of Sweden in 2009 to that in 2010?
Make the answer very short. 0.91. What is the ratio of the Imports (% of total merchandise imports) in Sub-Saharan Africa (developing only) in 2009 to that in 2011?
Your response must be concise. 0.85. What is the ratio of the Imports (% of total merchandise imports) of Azerbaijan in 2009 to that in 2011?
Offer a very short reply. 1.18. What is the ratio of the Imports (% of total merchandise imports) in Sweden in 2009 to that in 2011?
Provide a succinct answer. 0.79. What is the ratio of the Imports (% of total merchandise imports) in Sub-Saharan Africa (developing only) in 2009 to that in 2012?
Give a very brief answer. 0.87. What is the ratio of the Imports (% of total merchandise imports) of Azerbaijan in 2009 to that in 2012?
Offer a very short reply. 1.02. What is the ratio of the Imports (% of total merchandise imports) of Sweden in 2009 to that in 2012?
Your response must be concise. 0.86. What is the ratio of the Imports (% of total merchandise imports) of Sub-Saharan Africa (developing only) in 2009 to that in 2013?
Offer a very short reply. 0.83. What is the ratio of the Imports (% of total merchandise imports) in Azerbaijan in 2009 to that in 2013?
Your response must be concise. 1.13. What is the ratio of the Imports (% of total merchandise imports) of Sweden in 2009 to that in 2013?
Your answer should be compact. 0.8. What is the ratio of the Imports (% of total merchandise imports) of Sub-Saharan Africa (developing only) in 2010 to that in 2011?
Keep it short and to the point. 0.82. What is the ratio of the Imports (% of total merchandise imports) of Azerbaijan in 2010 to that in 2011?
Provide a succinct answer. 1.11. What is the ratio of the Imports (% of total merchandise imports) in Sweden in 2010 to that in 2011?
Your answer should be compact. 0.87. What is the ratio of the Imports (% of total merchandise imports) of Sub-Saharan Africa (developing only) in 2010 to that in 2012?
Give a very brief answer. 0.84. What is the ratio of the Imports (% of total merchandise imports) in Azerbaijan in 2010 to that in 2012?
Keep it short and to the point. 0.96. What is the ratio of the Imports (% of total merchandise imports) in Sweden in 2010 to that in 2012?
Offer a very short reply. 0.94. What is the ratio of the Imports (% of total merchandise imports) in Sub-Saharan Africa (developing only) in 2010 to that in 2013?
Your answer should be very brief. 0.8. What is the ratio of the Imports (% of total merchandise imports) of Azerbaijan in 2010 to that in 2013?
Provide a short and direct response. 1.06. What is the ratio of the Imports (% of total merchandise imports) of Sweden in 2010 to that in 2013?
Provide a succinct answer. 0.88. What is the ratio of the Imports (% of total merchandise imports) in Sub-Saharan Africa (developing only) in 2011 to that in 2012?
Offer a very short reply. 1.03. What is the ratio of the Imports (% of total merchandise imports) of Azerbaijan in 2011 to that in 2012?
Keep it short and to the point. 0.86. What is the ratio of the Imports (% of total merchandise imports) in Sweden in 2011 to that in 2012?
Your response must be concise. 1.08. What is the ratio of the Imports (% of total merchandise imports) in Sub-Saharan Africa (developing only) in 2011 to that in 2013?
Provide a succinct answer. 0.98. What is the ratio of the Imports (% of total merchandise imports) of Azerbaijan in 2011 to that in 2013?
Your answer should be very brief. 0.96. What is the ratio of the Imports (% of total merchandise imports) in Sweden in 2011 to that in 2013?
Provide a short and direct response. 1.01. What is the ratio of the Imports (% of total merchandise imports) in Sub-Saharan Africa (developing only) in 2012 to that in 2013?
Your answer should be very brief. 0.95. What is the ratio of the Imports (% of total merchandise imports) in Azerbaijan in 2012 to that in 2013?
Offer a terse response. 1.11. What is the ratio of the Imports (% of total merchandise imports) in Sweden in 2012 to that in 2013?
Ensure brevity in your answer.  0.94. What is the difference between the highest and the second highest Imports (% of total merchandise imports) of Sub-Saharan Africa (developing only)?
Offer a terse response. 0.05. What is the difference between the highest and the second highest Imports (% of total merchandise imports) in Azerbaijan?
Give a very brief answer. 0.48. What is the difference between the highest and the second highest Imports (% of total merchandise imports) of Sweden?
Ensure brevity in your answer.  0.01. What is the difference between the highest and the lowest Imports (% of total merchandise imports) in Sub-Saharan Africa (developing only)?
Your answer should be compact. 0.46. What is the difference between the highest and the lowest Imports (% of total merchandise imports) of Azerbaijan?
Give a very brief answer. 4.29. What is the difference between the highest and the lowest Imports (% of total merchandise imports) in Sweden?
Provide a succinct answer. 0.3. 